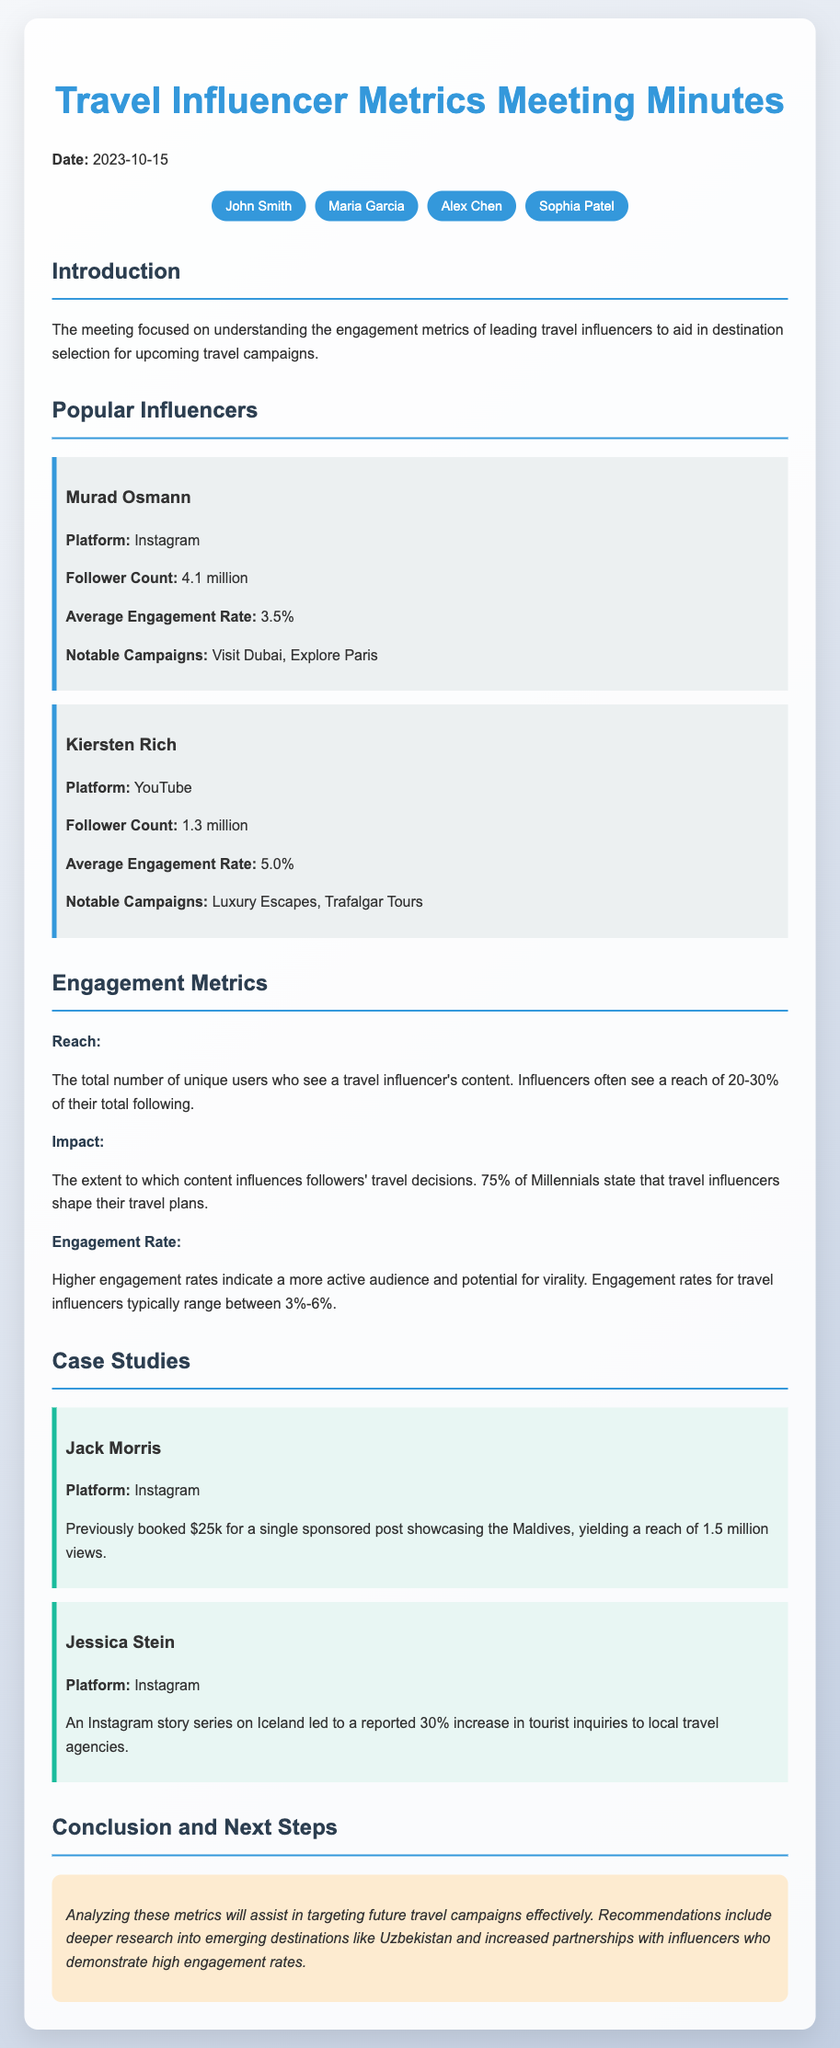What was the date of the meeting? The meeting took place on the date specified in the document, which is mentioned clearly in the introductory section.
Answer: 2023-10-15 Who is the influencer with the highest follower count? The document provides details about multiple influencers, and Murad Osmann has the highest follower count listed.
Answer: Murad Osmann What is the average engagement rate for Kiersten Rich? The engagement rate is specifically mentioned alongside each influencer's details in the document, particularly for Kiersten Rich.
Answer: 5.0% What percentage of Millennials state that travel influencers shape their travel plans? The document includes statistics about the influence of travel influencers on Millennials, which is stated clearly.
Answer: 75% Which influencer previously booked a $25k sponsored post? The case study section lists influencers along with their notable financial achievements, specifically mentioning Jack Morris' booking.
Answer: Jack Morris What notable campaign did Murad Osmann participate in? Notable campaigns are associated with each influencer, providing specific examples of their work, particularly for Murad Osmann.
Answer: Visit Dubai What is the typical engagement rate range for travel influencers? The engagement rate is discussed in the metrics section with a specific range mentioned for travel influencers.
Answer: 3%-6% Which destination showed a reported 30% increase in tourist inquiries due to Jessica Stein's campaign? This information is detailed in the case study about Jessica Stein, specifically mentioning the impact of her Instagram story series.
Answer: Iceland What is the conclusion about targeting future travel campaigns? The conclusion summarizes recommendations based on the analysis of metrics presented in the meeting minutes, specifically aimed at travel campaigns.
Answer: Targeting effective campaigns 